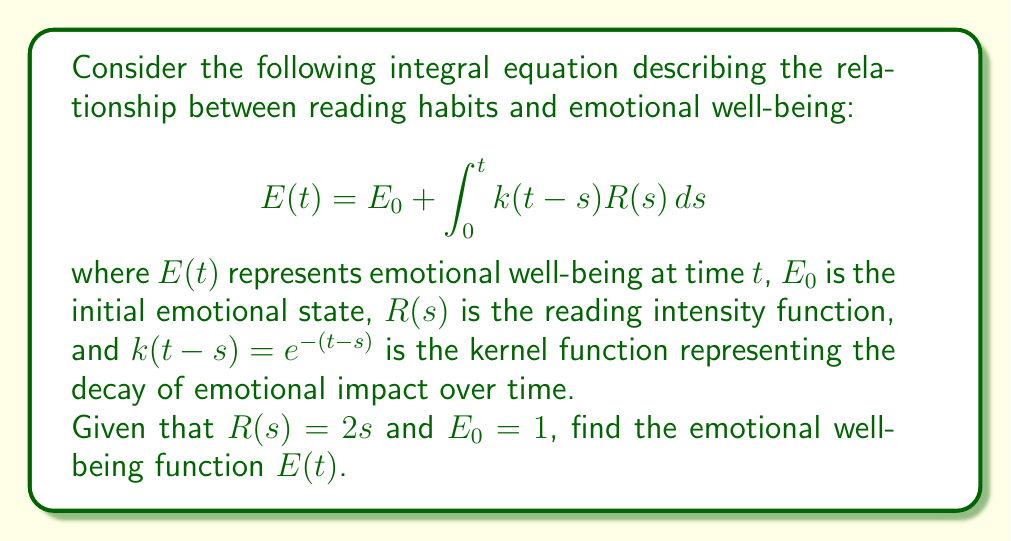Can you solve this math problem? To solve this integral equation, we'll follow these steps:

1) Substitute the given functions into the equation:
   $$E(t) = 1 + \int_0^t e^{-(t-s)}(2s)ds$$

2) Expand the integral:
   $$E(t) = 1 + 2\int_0^t e^{-(t-s)}s ds$$

3) Use integration by parts with $u = s$ and $dv = e^{-(t-s)}ds$:
   $$E(t) = 1 + 2\left[-se^{-(t-s)}\right]_0^t + 2\int_0^t e^{-(t-s)}ds$$

4) Evaluate the first part:
   $$E(t) = 1 + 2\left[-te^{-(t-t)} + 0\cdot e^{-(t-0)}\right] + 2\int_0^t e^{-(t-s)}ds$$
   $$E(t) = 1 - 2t + 2\int_0^t e^{-(t-s)}ds$$

5) Solve the remaining integral:
   $$E(t) = 1 - 2t + 2\left[-e^{-(t-s)}\right]_0^t$$
   $$E(t) = 1 - 2t + 2\left[-e^0 + e^{-t}\right]$$
   $$E(t) = 1 - 2t - 2 + 2e^{-t}$$

6) Simplify:
   $$E(t) = -1 - 2t + 2e^{-t}$$

This is the final solution for the emotional well-being function $E(t)$.
Answer: $E(t) = -1 - 2t + 2e^{-t}$ 